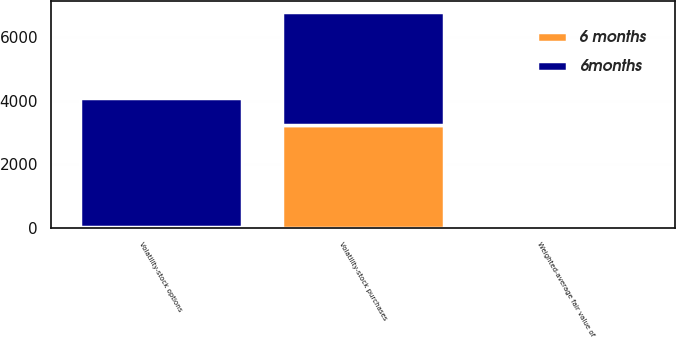Convert chart. <chart><loc_0><loc_0><loc_500><loc_500><stacked_bar_chart><ecel><fcel>Volatility-stock options<fcel>Volatility-stock purchases<fcel>Weighted-average fair value of<nl><fcel>6 months<fcel>40<fcel>3244<fcel>5.56<nl><fcel>6months<fcel>4063<fcel>3544<fcel>4.24<nl></chart> 